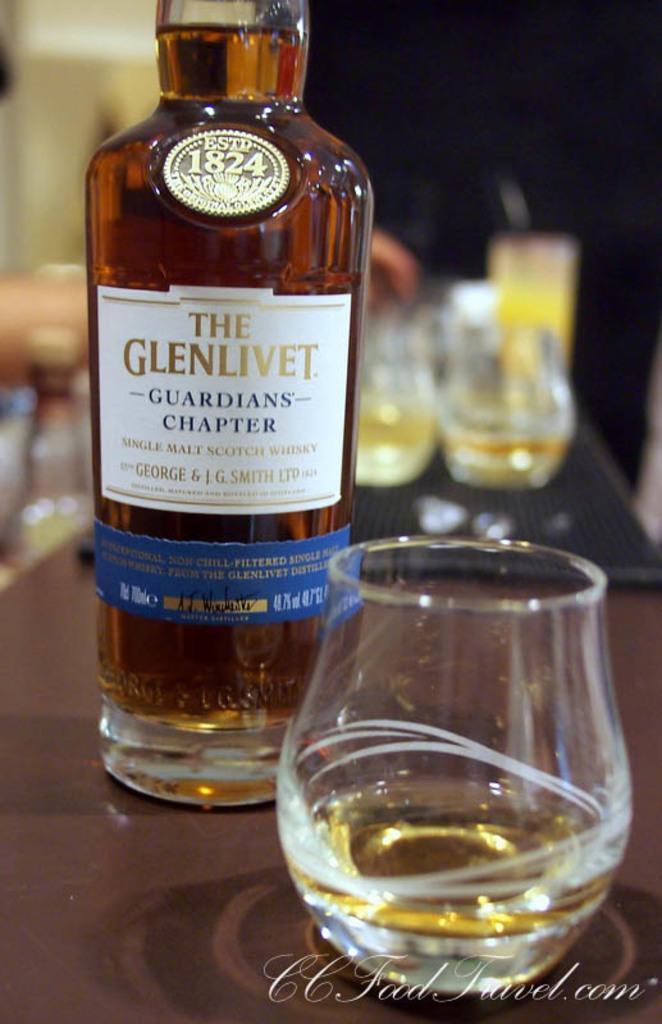<image>
Present a compact description of the photo's key features. the word Glenlivet that is on a bottle 